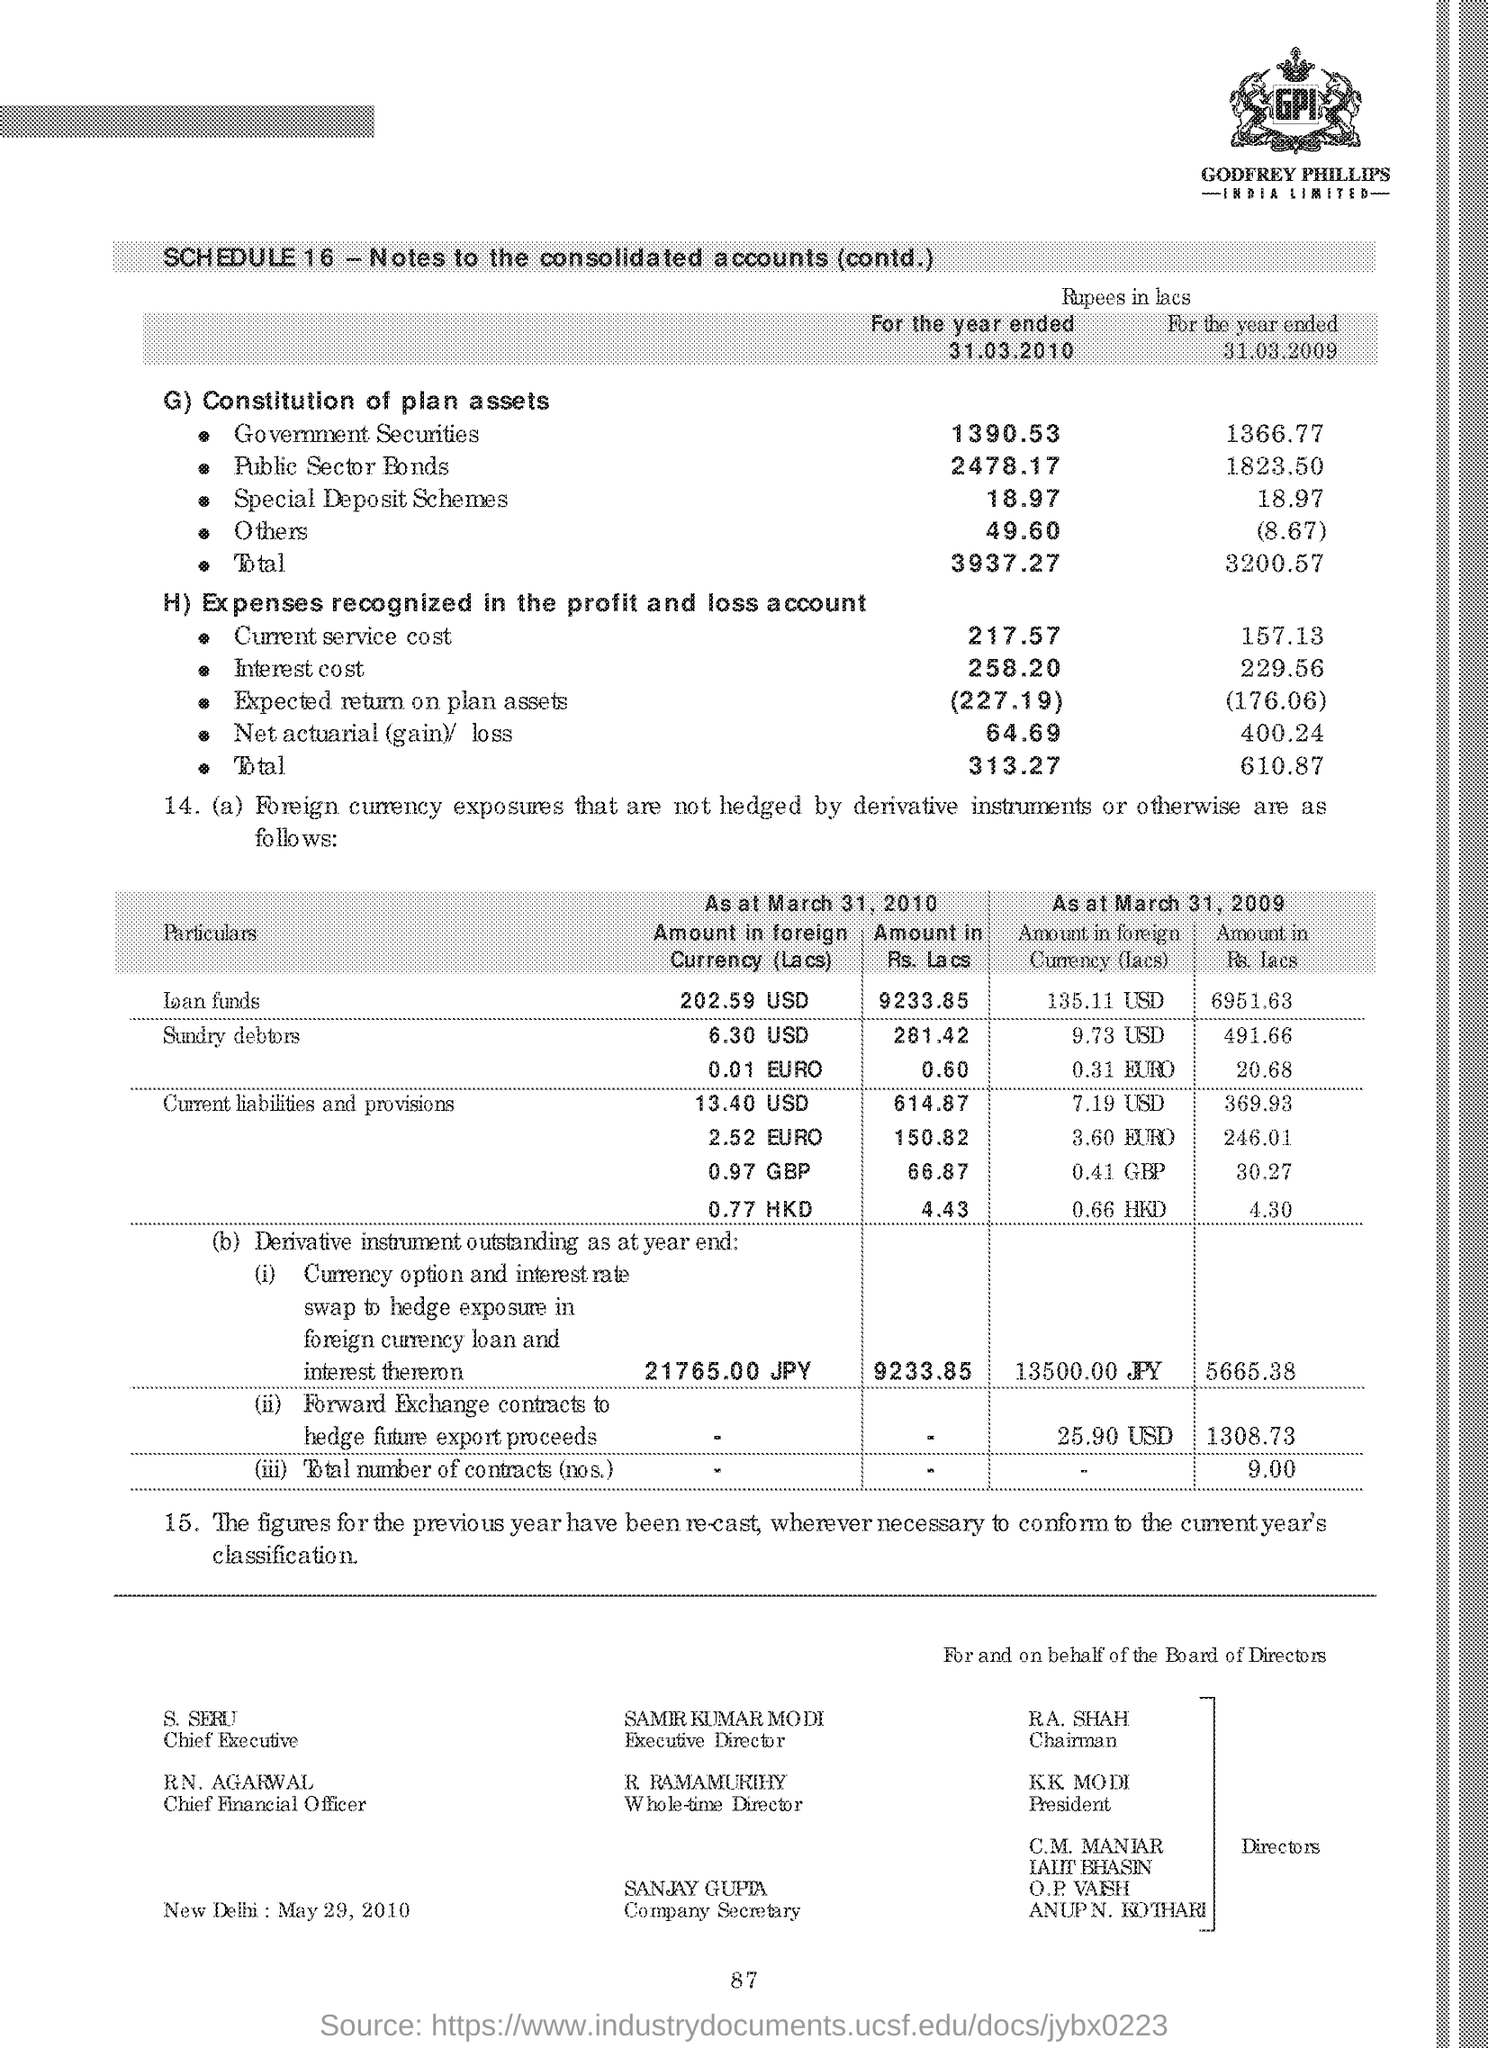Who is the Chairman?
Provide a succinct answer. RA. Shah. Who is the President?
Give a very brief answer. KK Modi. Who is the Executive Director?
Keep it short and to the point. Samir Kumar Modi. Who is the Company Secretary?
Provide a succinct answer. Sanjay Gupta. Who is the Whole-time Director?
Your answer should be very brief. R Ramamurthy. 